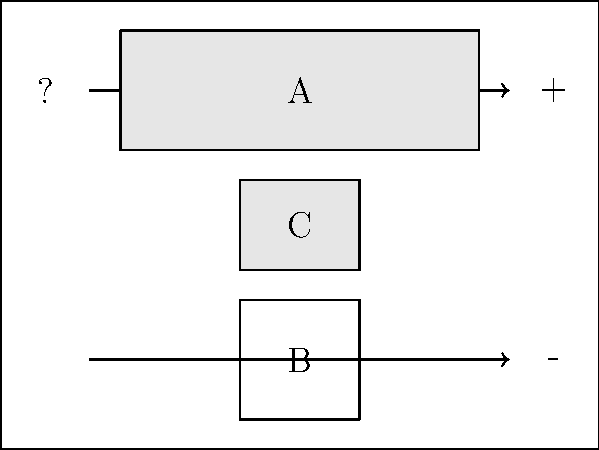In this basic solar panel setup schematic, identify the components labeled A, B, and C. To identify the components in this basic solar panel setup, let's analyze each labeled part:

1. Component A:
   - Located at the top of the schematic
   - Represented by a rectangular shape
   - Connected to the positive and negative lines
   This is the solar panel, which converts sunlight into electrical energy.

2. Component B:
   - Located at the bottom of the schematic
   - Represented by two parallel lines (one longer than the other)
   - Connected to the positive and negative lines
   This is the battery, which stores the electrical energy generated by the solar panel.

3. Component C:
   - Located between the solar panel and the battery
   - Represented by a small rectangular shape
   - Connected to both the solar panel and the battery
   This is the charge controller, which regulates the charging process of the battery and prevents overcharging.

The arrows on the lines indicate the direction of current flow from the solar panel to the battery through the charge controller.
Answer: A: Solar panel, B: Battery, C: Charge controller 